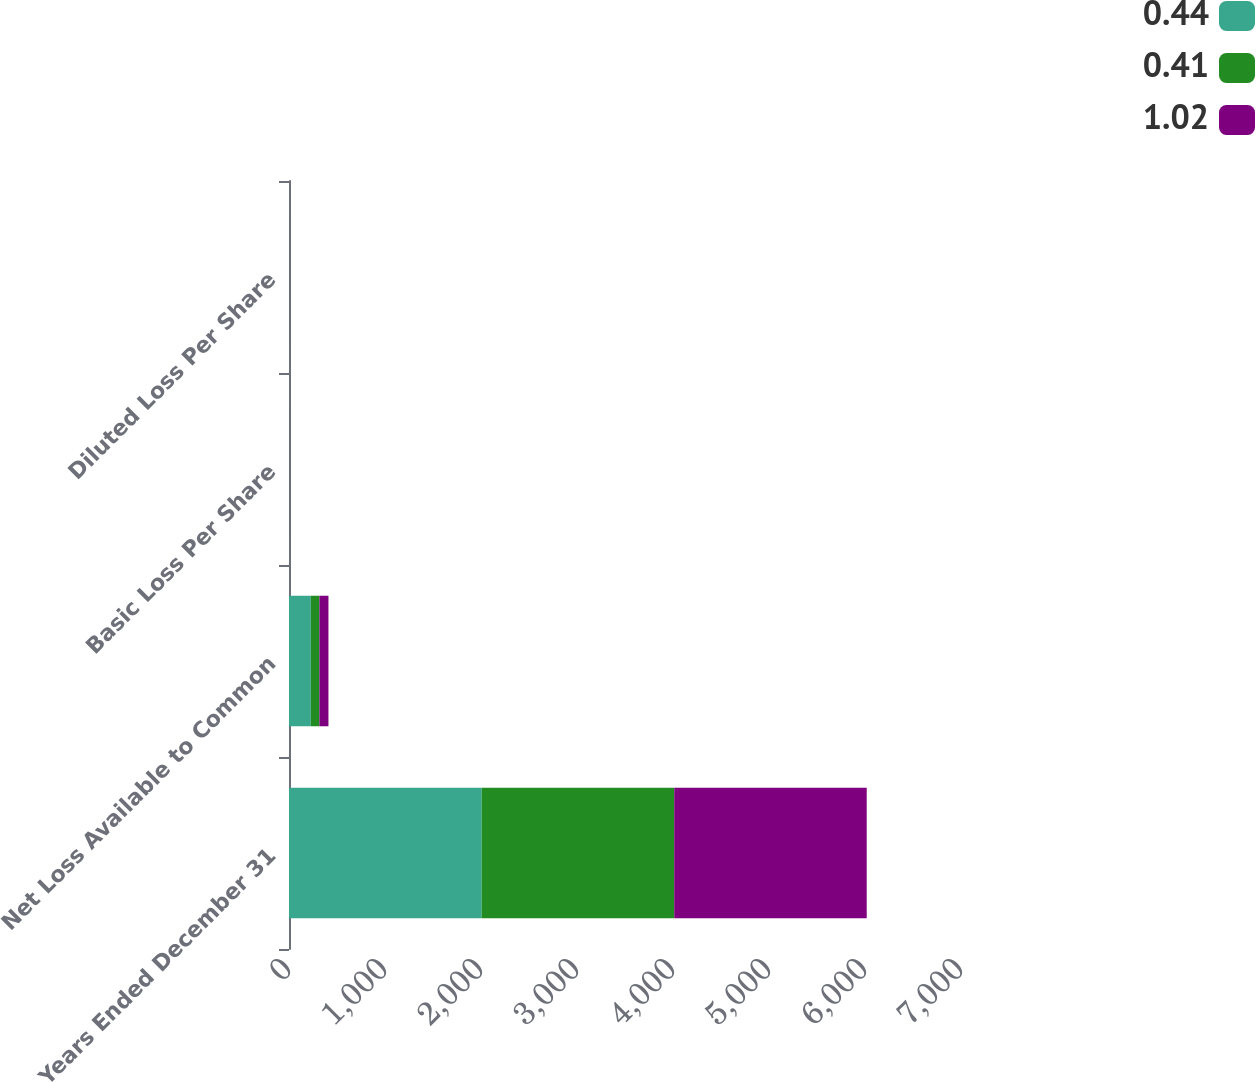Convert chart to OTSL. <chart><loc_0><loc_0><loc_500><loc_500><stacked_bar_chart><ecel><fcel>Years Ended December 31<fcel>Net Loss Available to Common<fcel>Basic Loss Per Share<fcel>Diluted Loss Per Share<nl><fcel>0.44<fcel>2007<fcel>227<fcel>1.02<fcel>1.02<nl><fcel>0.41<fcel>2006<fcel>90<fcel>0.41<fcel>0.41<nl><fcel>1.02<fcel>2005<fcel>94<fcel>0.44<fcel>0.44<nl></chart> 